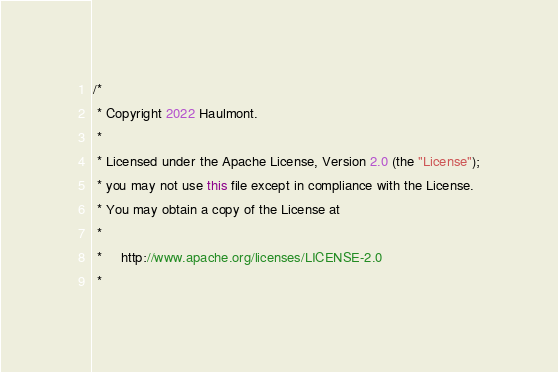Convert code to text. <code><loc_0><loc_0><loc_500><loc_500><_Java_>/*
 * Copyright 2022 Haulmont.
 *
 * Licensed under the Apache License, Version 2.0 (the "License");
 * you may not use this file except in compliance with the License.
 * You may obtain a copy of the License at
 *
 *     http://www.apache.org/licenses/LICENSE-2.0
 *</code> 